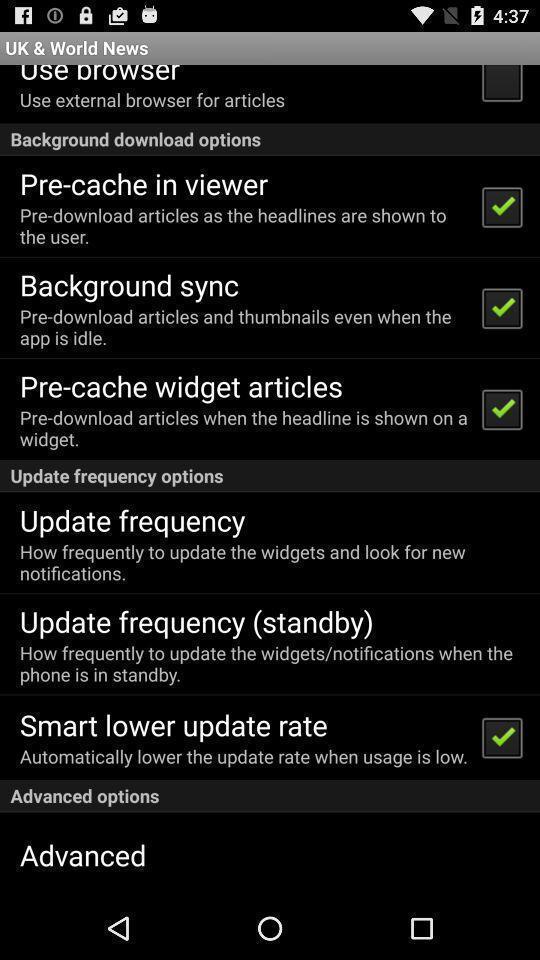Describe the content in this image. Page showing list of options of a news app. 